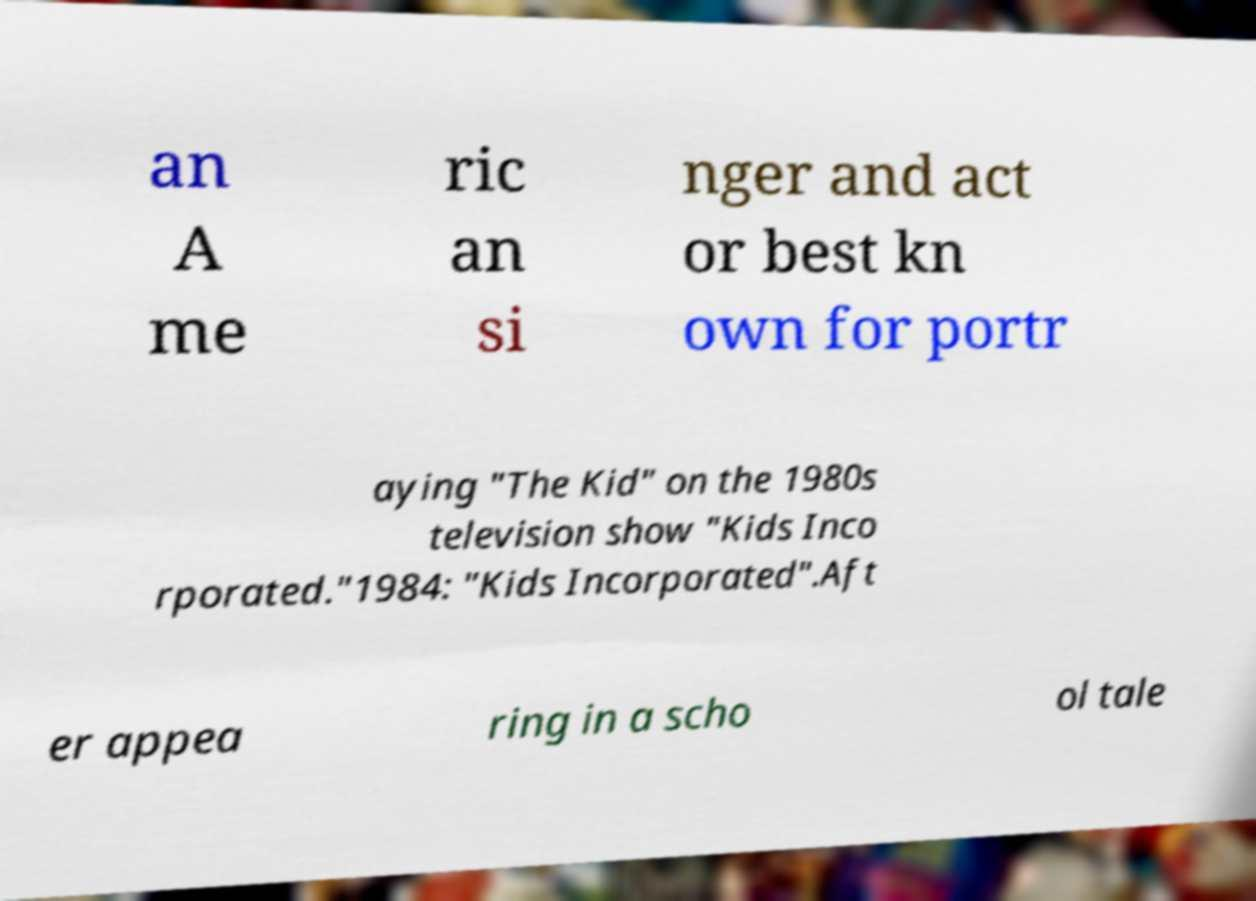There's text embedded in this image that I need extracted. Can you transcribe it verbatim? an A me ric an si nger and act or best kn own for portr aying "The Kid" on the 1980s television show "Kids Inco rporated."1984: "Kids Incorporated".Aft er appea ring in a scho ol tale 